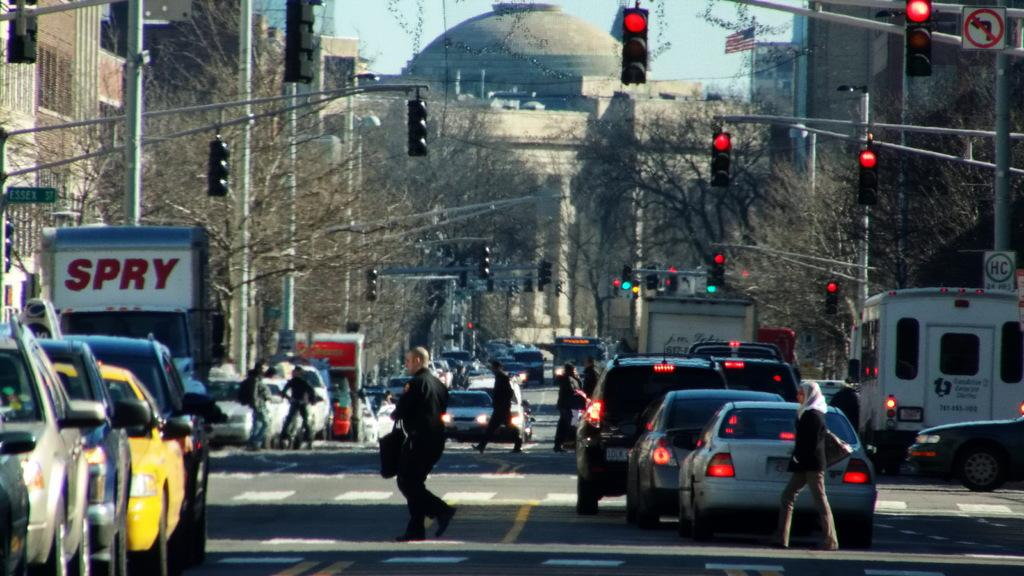<image>
Share a concise interpretation of the image provided. A crowded city street with a truck that has "Spry" written across the top. 